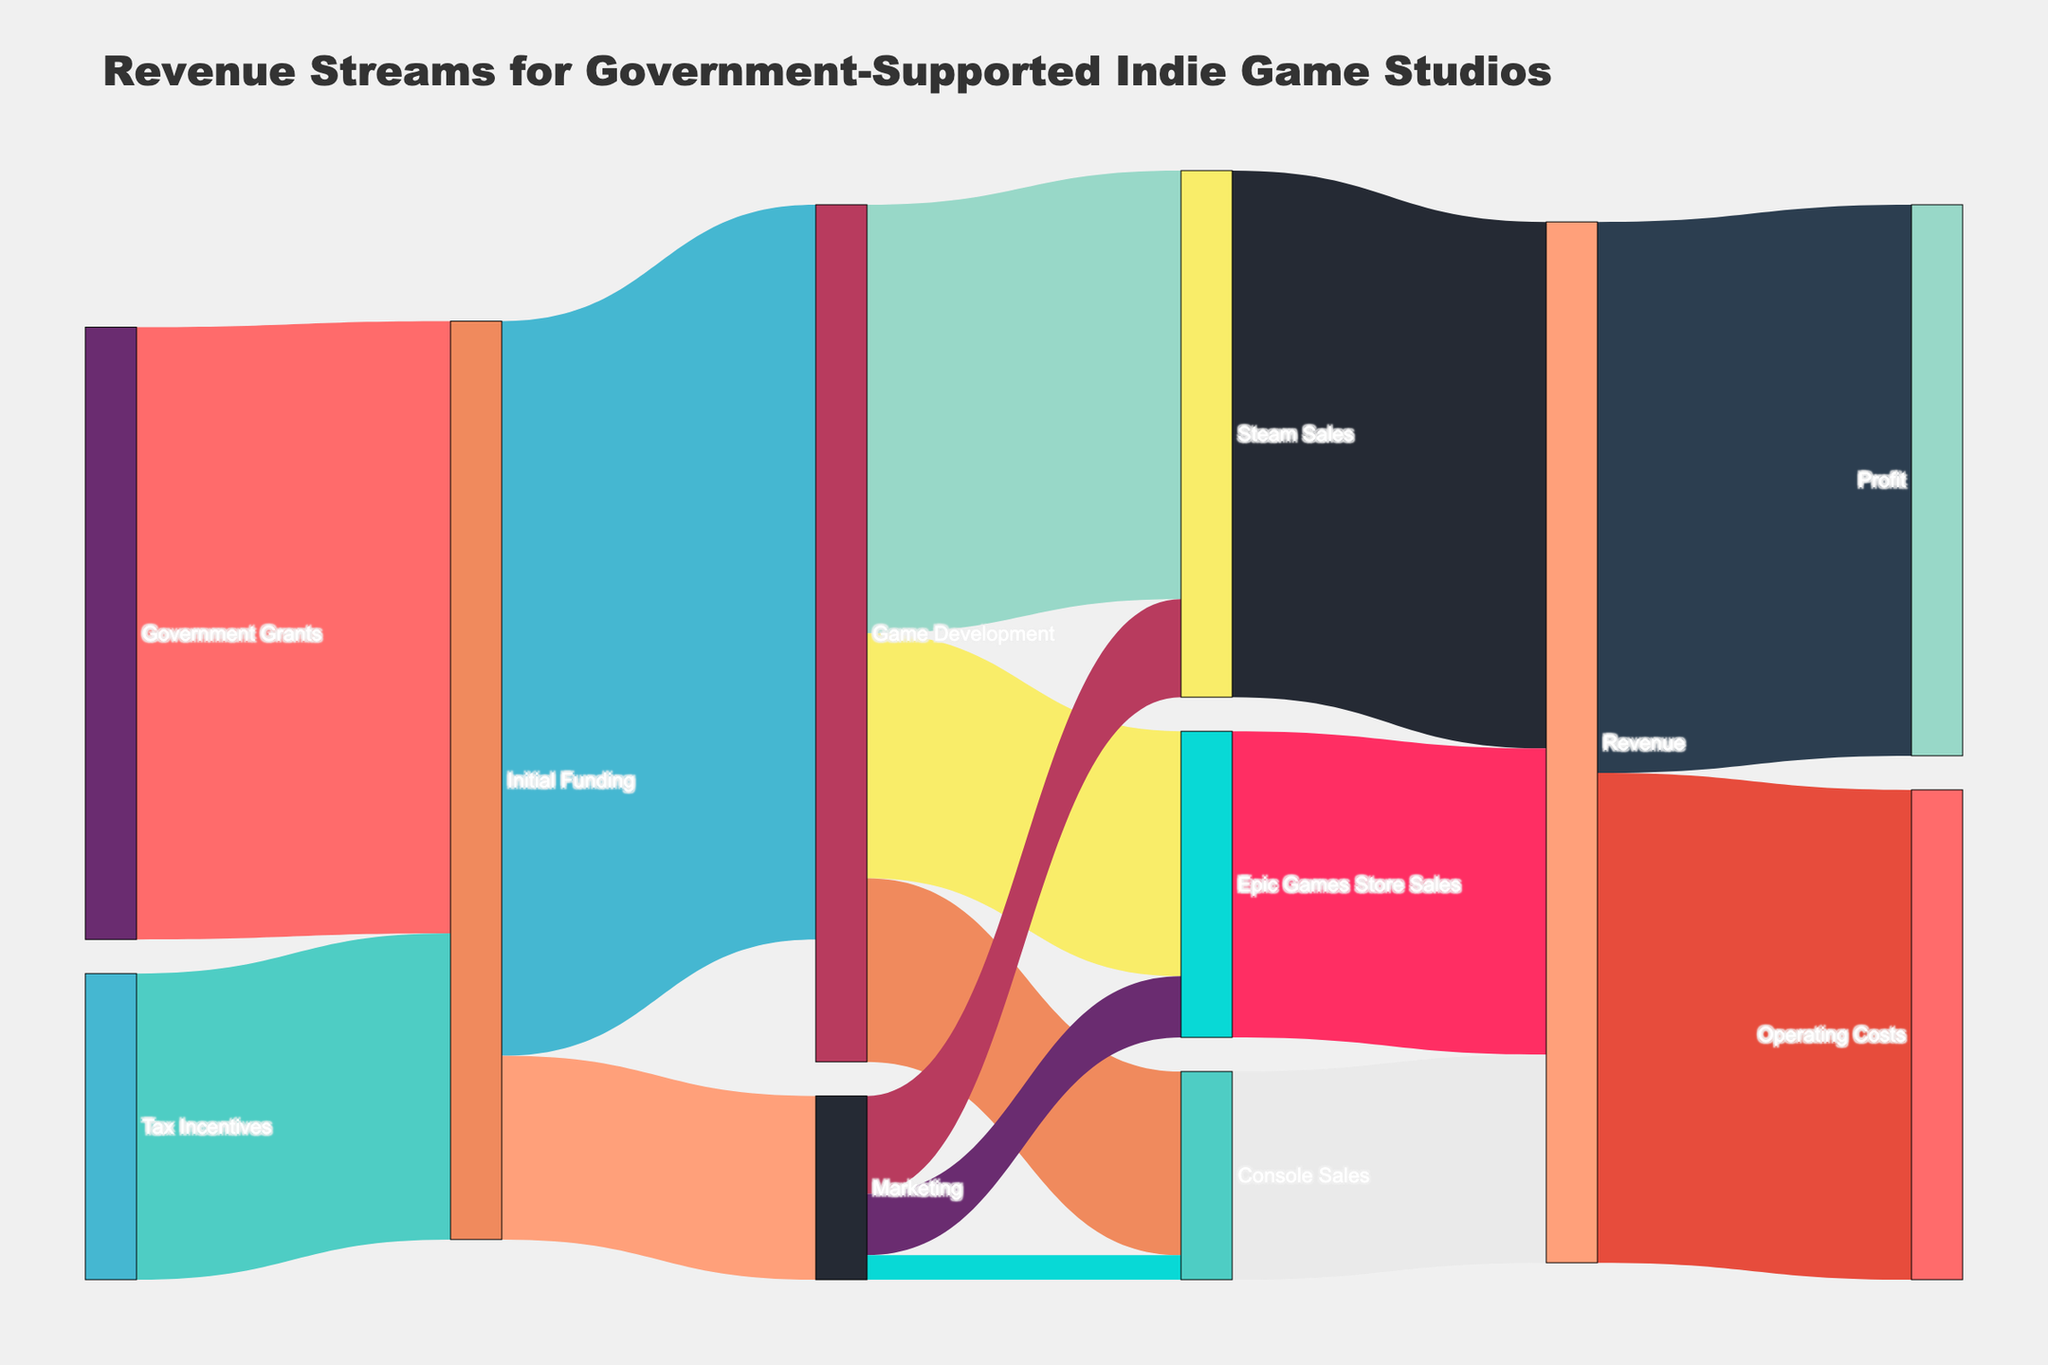What is the initial funding amount from Government Grants? According to the visual connections in the diagram, the flow from 'Government Grants' to 'Initial Funding' shows a value of 500000.
Answer: 500000 What is the total revenue from all sales channels combined? The figure shows revenues from 'Steam Sales' (430000), 'Epic Games Store Sales' (250000), and 'Console Sales' (170000). Summing these values gives 850000.
Answer: 850000 Which sales channel generated the highest revenue? The links show the revenue amounts: 'Steam Sales' (430000), 'Epic Games Store Sales' (250000), and 'Console Sales' (170000). Among these, 'Steam Sales' has the highest value.
Answer: Steam Sales How much funding is allocated to Game Development from the Initial Funding? The diagram shows that 'Game Development' receives 600000 from 'Initial Funding'.
Answer: 600000 How much profit is generated from the total revenue? The diagram shows that 'Revenue' flows 450000 into 'Profit'.
Answer: 450000 What is the combined value of initial funding from Government Grants and Tax Incentives? The figure shows 500000 from 'Government Grants' and 250000 from 'Tax Incentives'. Adding these values results in 750000.
Answer: 750000 How does the amount allocated for Marketing compare to that for Game Development? The diagram indicates 'Marketing' receives 150000 while 'Game Development' receives 600000 from 'Initial Funding'. Since 150000 is less than 600000, 'Marketing' receives less.
Answer: Marketing receives less What percentage of total revenue is allocated to Operating Costs? The figure shows that 'Operating Costs' are 400000 out of 850000 total revenue. The percentage is calculated as (400000 / 850000) * 100, which is approximately 47.06%.
Answer: 47.06% What is the total allocation for Marketing and Game Development combined? From 'Initial Funding', 'Marketing' receives 150000 and 'Game Development' receives 600000. Summing these values yields 750000.
Answer: 750000 How do the game sales from Epic Games Store compare to Console Sales? The figure indicates that 'Epic Games Store Sales' amount to 250000, while 'Console Sales' amount to 170000. Since 250000 is greater than 170000, 'Epic Games Store Sales' are higher.
Answer: Epic Games Store Sales are higher 